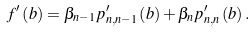<formula> <loc_0><loc_0><loc_500><loc_500>f ^ { \prime } \left ( b \right ) = \beta _ { n - 1 } p _ { n , n - 1 } ^ { \prime } \left ( b \right ) + \beta _ { n } p _ { n , n } ^ { \prime } \left ( b \right ) .</formula> 